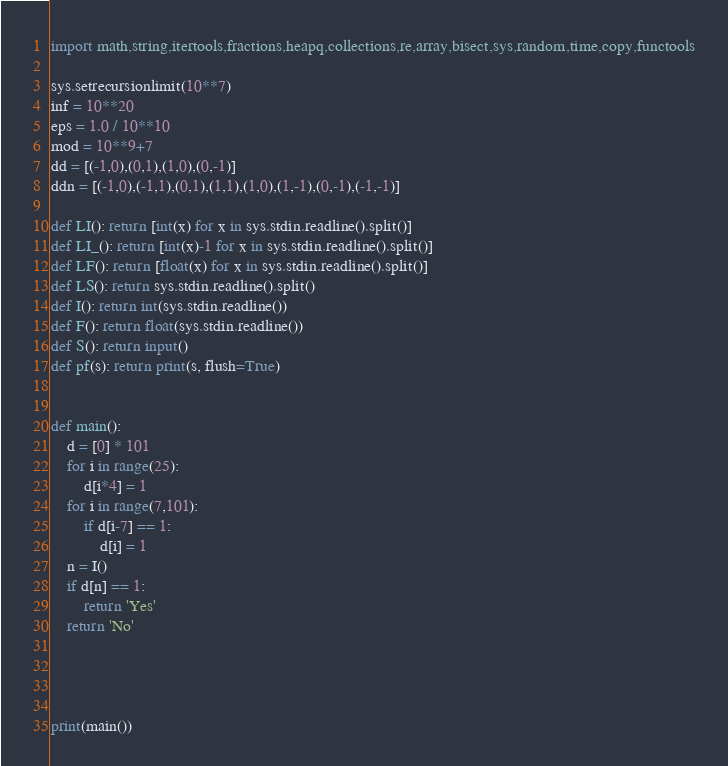<code> <loc_0><loc_0><loc_500><loc_500><_Python_>import math,string,itertools,fractions,heapq,collections,re,array,bisect,sys,random,time,copy,functools

sys.setrecursionlimit(10**7)
inf = 10**20
eps = 1.0 / 10**10
mod = 10**9+7
dd = [(-1,0),(0,1),(1,0),(0,-1)]
ddn = [(-1,0),(-1,1),(0,1),(1,1),(1,0),(1,-1),(0,-1),(-1,-1)]

def LI(): return [int(x) for x in sys.stdin.readline().split()]
def LI_(): return [int(x)-1 for x in sys.stdin.readline().split()]
def LF(): return [float(x) for x in sys.stdin.readline().split()]
def LS(): return sys.stdin.readline().split()
def I(): return int(sys.stdin.readline())
def F(): return float(sys.stdin.readline())
def S(): return input()
def pf(s): return print(s, flush=True)


def main():
    d = [0] * 101
    for i in range(25):
        d[i*4] = 1
    for i in range(7,101):
        if d[i-7] == 1:
            d[i] = 1
    n = I()
    if d[n] == 1:
        return 'Yes'
    return 'No'




print(main())
</code> 